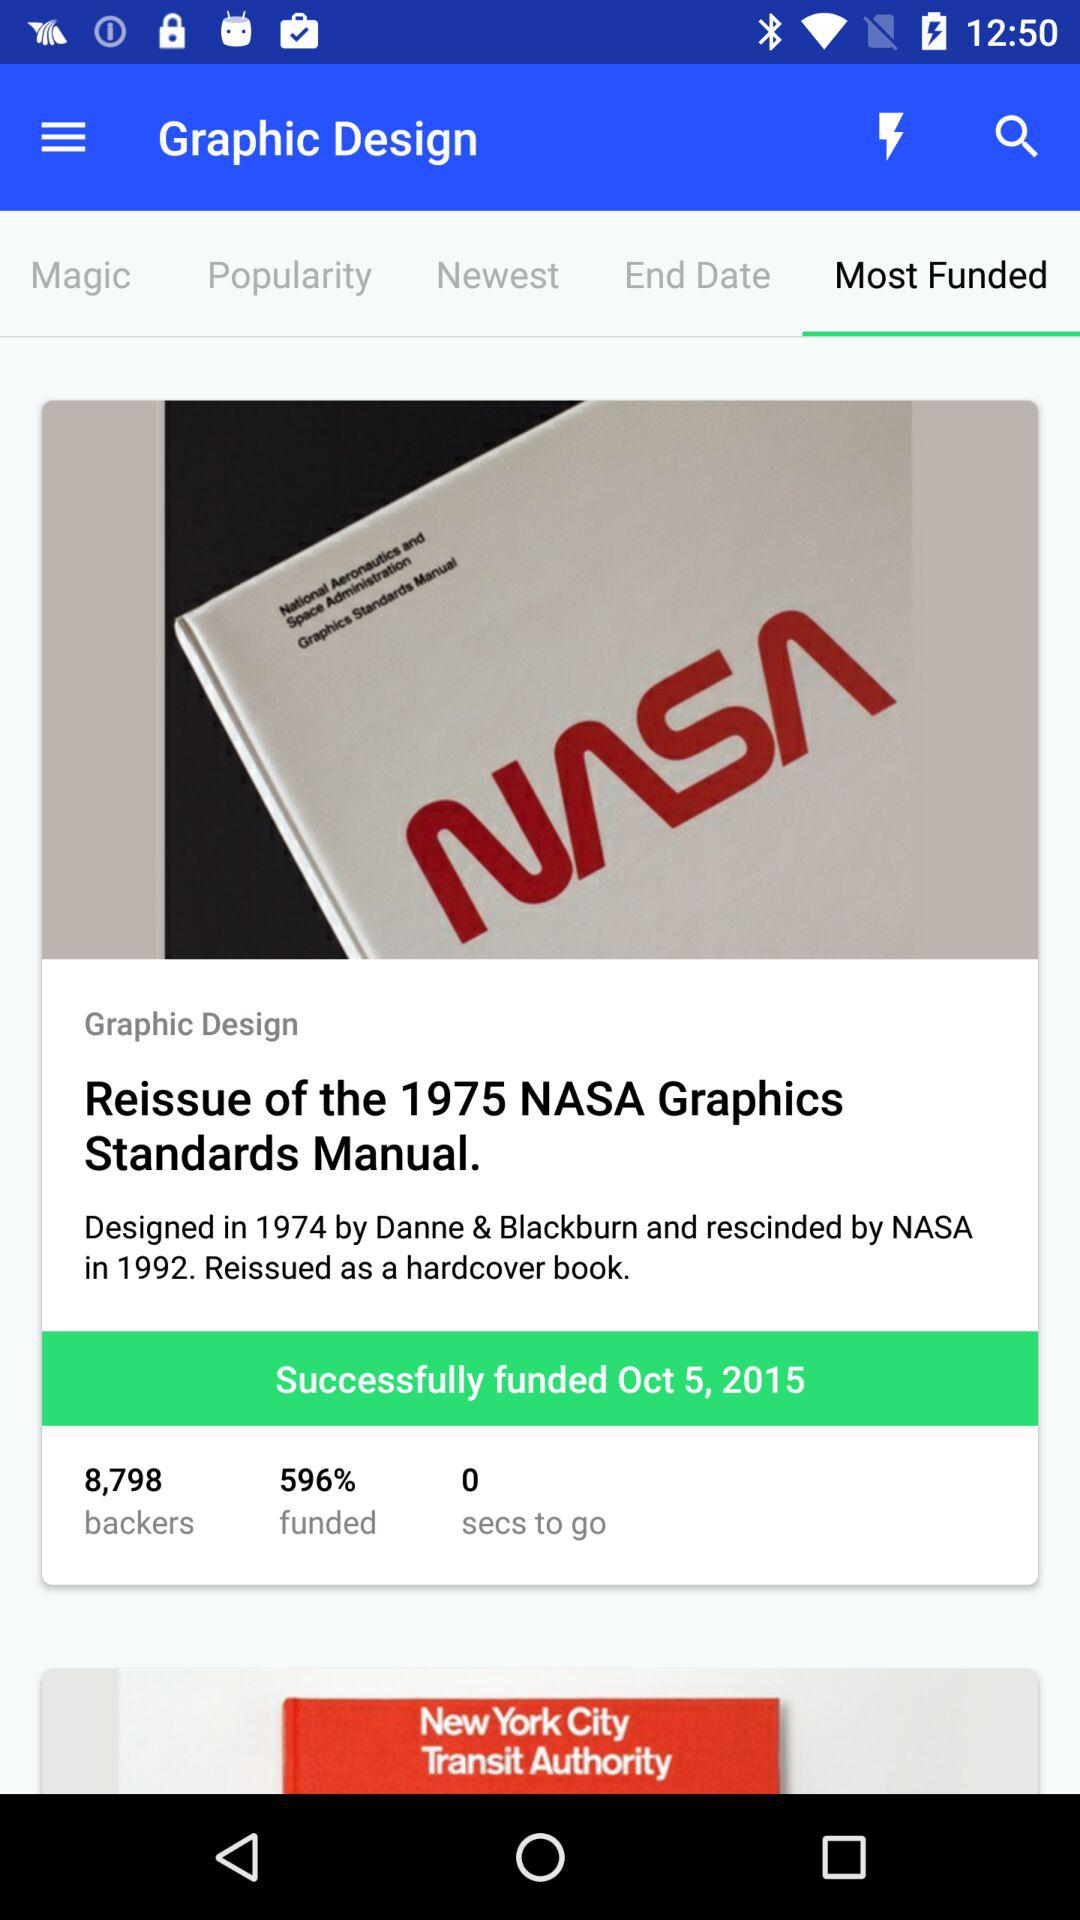What tab is selected? The selected tab is "Most Funded". 